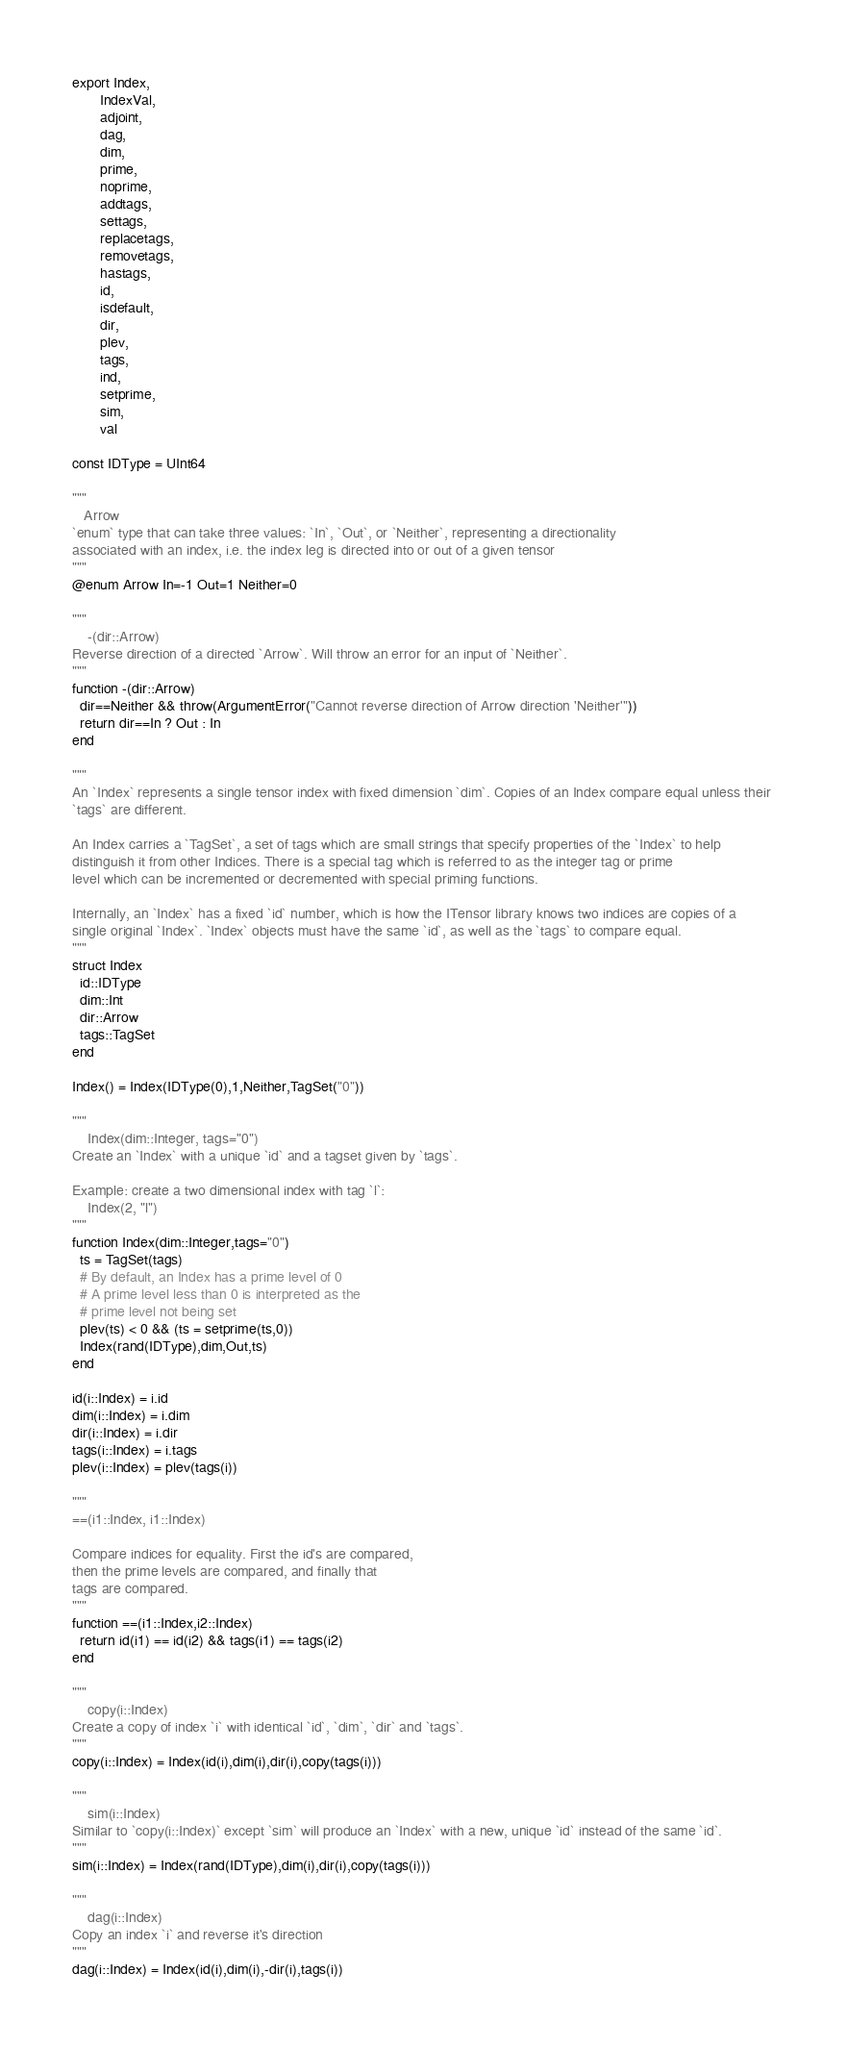<code> <loc_0><loc_0><loc_500><loc_500><_Julia_>export Index,
       IndexVal,
       adjoint,
       dag,
       dim,
       prime,
       noprime,
       addtags,
       settags,
       replacetags,
       removetags,
       hastags,
       id,
       isdefault,
       dir,
       plev,
       tags,
       ind,
       setprime,
       sim,
       val

const IDType = UInt64

"""
   Arrow
`enum` type that can take three values: `In`, `Out`, or `Neither`, representing a directionality
associated with an index, i.e. the index leg is directed into or out of a given tensor
"""
@enum Arrow In=-1 Out=1 Neither=0

"""
    -(dir::Arrow)
Reverse direction of a directed `Arrow`. Will throw an error for an input of `Neither`.
"""
function -(dir::Arrow)
  dir==Neither && throw(ArgumentError("Cannot reverse direction of Arrow direction 'Neither'"))
  return dir==In ? Out : In
end

"""
An `Index` represents a single tensor index with fixed dimension `dim`. Copies of an Index compare equal unless their 
`tags` are different.

An Index carries a `TagSet`, a set of tags which are small strings that specify properties of the `Index` to help 
distinguish it from other Indices. There is a special tag which is referred to as the integer tag or prime 
level which can be incremented or decremented with special priming functions.

Internally, an `Index` has a fixed `id` number, which is how the ITensor library knows two indices are copies of a 
single original `Index`. `Index` objects must have the same `id`, as well as the `tags` to compare equal.
"""
struct Index
  id::IDType
  dim::Int
  dir::Arrow
  tags::TagSet
end

Index() = Index(IDType(0),1,Neither,TagSet("0"))

"""
    Index(dim::Integer, tags="0")
Create an `Index` with a unique `id` and a tagset given by `tags`.

Example: create a two dimensional index with tag `l`:
    Index(2, "l")
"""
function Index(dim::Integer,tags="0")
  ts = TagSet(tags)
  # By default, an Index has a prime level of 0
  # A prime level less than 0 is interpreted as the
  # prime level not being set
  plev(ts) < 0 && (ts = setprime(ts,0))
  Index(rand(IDType),dim,Out,ts)
end

id(i::Index) = i.id
dim(i::Index) = i.dim
dir(i::Index) = i.dir
tags(i::Index) = i.tags
plev(i::Index) = plev(tags(i))

"""
==(i1::Index, i1::Index)

Compare indices for equality. First the id's are compared,
then the prime levels are compared, and finally that
tags are compared.
"""
function ==(i1::Index,i2::Index)
  return id(i1) == id(i2) && tags(i1) == tags(i2)
end

"""
    copy(i::Index)
Create a copy of index `i` with identical `id`, `dim`, `dir` and `tags`.
"""
copy(i::Index) = Index(id(i),dim(i),dir(i),copy(tags(i)))

"""
    sim(i::Index)
Similar to `copy(i::Index)` except `sim` will produce an `Index` with a new, unique `id` instead of the same `id`.
"""
sim(i::Index) = Index(rand(IDType),dim(i),dir(i),copy(tags(i)))

"""
    dag(i::Index)
Copy an index `i` and reverse it's direction
"""
dag(i::Index) = Index(id(i),dim(i),-dir(i),tags(i))
</code> 